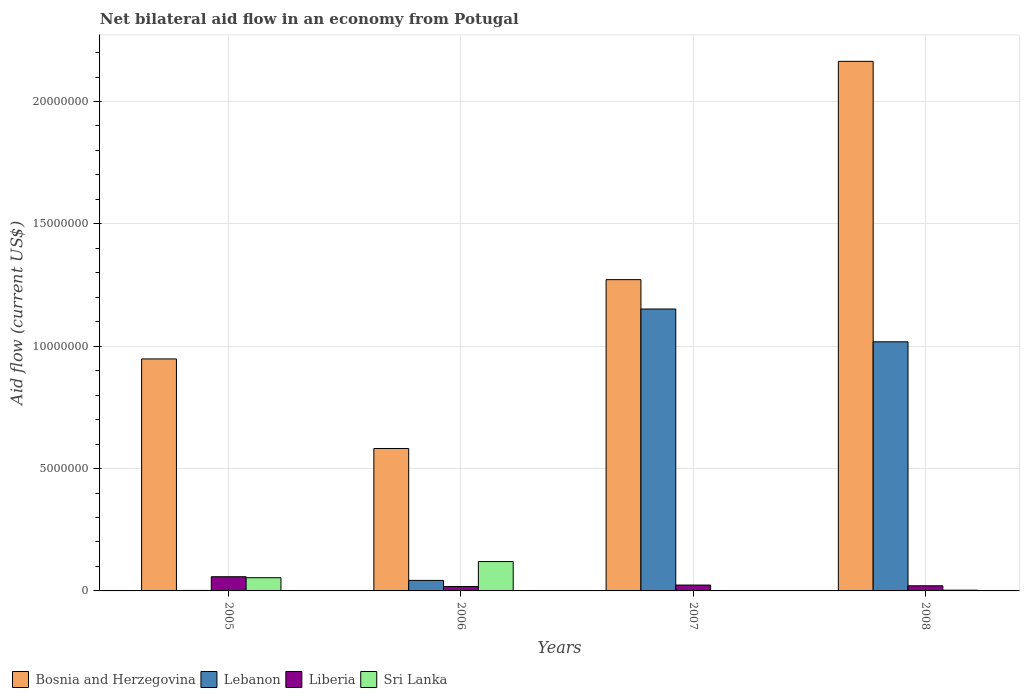How many groups of bars are there?
Offer a terse response. 4. Are the number of bars per tick equal to the number of legend labels?
Provide a short and direct response. Yes. How many bars are there on the 2nd tick from the left?
Your response must be concise. 4. How many bars are there on the 4th tick from the right?
Your response must be concise. 4. What is the label of the 2nd group of bars from the left?
Provide a succinct answer. 2006. In how many cases, is the number of bars for a given year not equal to the number of legend labels?
Your answer should be compact. 0. What is the net bilateral aid flow in Lebanon in 2005?
Provide a succinct answer. 2.00e+04. Across all years, what is the maximum net bilateral aid flow in Bosnia and Herzegovina?
Your answer should be compact. 2.16e+07. Across all years, what is the minimum net bilateral aid flow in Bosnia and Herzegovina?
Provide a succinct answer. 5.82e+06. In which year was the net bilateral aid flow in Liberia maximum?
Your answer should be compact. 2005. In which year was the net bilateral aid flow in Bosnia and Herzegovina minimum?
Your answer should be compact. 2006. What is the total net bilateral aid flow in Liberia in the graph?
Offer a very short reply. 1.21e+06. What is the difference between the net bilateral aid flow in Bosnia and Herzegovina in 2005 and that in 2006?
Your response must be concise. 3.66e+06. What is the difference between the net bilateral aid flow in Lebanon in 2005 and the net bilateral aid flow in Liberia in 2006?
Provide a succinct answer. -1.60e+05. What is the average net bilateral aid flow in Liberia per year?
Provide a short and direct response. 3.02e+05. In the year 2007, what is the difference between the net bilateral aid flow in Bosnia and Herzegovina and net bilateral aid flow in Sri Lanka?
Your answer should be compact. 1.27e+07. What is the ratio of the net bilateral aid flow in Sri Lanka in 2006 to that in 2007?
Offer a terse response. 120. Is the net bilateral aid flow in Lebanon in 2005 less than that in 2008?
Make the answer very short. Yes. What is the difference between the highest and the second highest net bilateral aid flow in Sri Lanka?
Offer a terse response. 6.60e+05. What is the difference between the highest and the lowest net bilateral aid flow in Liberia?
Your response must be concise. 4.00e+05. In how many years, is the net bilateral aid flow in Lebanon greater than the average net bilateral aid flow in Lebanon taken over all years?
Make the answer very short. 2. Is it the case that in every year, the sum of the net bilateral aid flow in Sri Lanka and net bilateral aid flow in Bosnia and Herzegovina is greater than the sum of net bilateral aid flow in Liberia and net bilateral aid flow in Lebanon?
Give a very brief answer. Yes. What does the 3rd bar from the left in 2008 represents?
Offer a very short reply. Liberia. What does the 2nd bar from the right in 2007 represents?
Your answer should be very brief. Liberia. Is it the case that in every year, the sum of the net bilateral aid flow in Bosnia and Herzegovina and net bilateral aid flow in Sri Lanka is greater than the net bilateral aid flow in Liberia?
Your response must be concise. Yes. How many years are there in the graph?
Provide a short and direct response. 4. Does the graph contain any zero values?
Make the answer very short. No. How many legend labels are there?
Offer a terse response. 4. How are the legend labels stacked?
Your response must be concise. Horizontal. What is the title of the graph?
Your response must be concise. Net bilateral aid flow in an economy from Potugal. Does "Lesotho" appear as one of the legend labels in the graph?
Ensure brevity in your answer.  No. What is the label or title of the Y-axis?
Your answer should be very brief. Aid flow (current US$). What is the Aid flow (current US$) in Bosnia and Herzegovina in 2005?
Your answer should be very brief. 9.48e+06. What is the Aid flow (current US$) in Lebanon in 2005?
Keep it short and to the point. 2.00e+04. What is the Aid flow (current US$) in Liberia in 2005?
Make the answer very short. 5.80e+05. What is the Aid flow (current US$) of Sri Lanka in 2005?
Keep it short and to the point. 5.40e+05. What is the Aid flow (current US$) of Bosnia and Herzegovina in 2006?
Make the answer very short. 5.82e+06. What is the Aid flow (current US$) of Lebanon in 2006?
Give a very brief answer. 4.30e+05. What is the Aid flow (current US$) of Sri Lanka in 2006?
Ensure brevity in your answer.  1.20e+06. What is the Aid flow (current US$) in Bosnia and Herzegovina in 2007?
Give a very brief answer. 1.27e+07. What is the Aid flow (current US$) of Lebanon in 2007?
Offer a very short reply. 1.15e+07. What is the Aid flow (current US$) of Bosnia and Herzegovina in 2008?
Make the answer very short. 2.16e+07. What is the Aid flow (current US$) in Lebanon in 2008?
Your response must be concise. 1.02e+07. What is the Aid flow (current US$) in Liberia in 2008?
Your answer should be compact. 2.10e+05. Across all years, what is the maximum Aid flow (current US$) in Bosnia and Herzegovina?
Keep it short and to the point. 2.16e+07. Across all years, what is the maximum Aid flow (current US$) in Lebanon?
Provide a succinct answer. 1.15e+07. Across all years, what is the maximum Aid flow (current US$) of Liberia?
Offer a terse response. 5.80e+05. Across all years, what is the maximum Aid flow (current US$) in Sri Lanka?
Provide a short and direct response. 1.20e+06. Across all years, what is the minimum Aid flow (current US$) of Bosnia and Herzegovina?
Keep it short and to the point. 5.82e+06. Across all years, what is the minimum Aid flow (current US$) in Lebanon?
Provide a succinct answer. 2.00e+04. Across all years, what is the minimum Aid flow (current US$) of Liberia?
Offer a terse response. 1.80e+05. Across all years, what is the minimum Aid flow (current US$) of Sri Lanka?
Offer a very short reply. 10000. What is the total Aid flow (current US$) of Bosnia and Herzegovina in the graph?
Give a very brief answer. 4.97e+07. What is the total Aid flow (current US$) in Lebanon in the graph?
Your answer should be compact. 2.22e+07. What is the total Aid flow (current US$) in Liberia in the graph?
Offer a very short reply. 1.21e+06. What is the total Aid flow (current US$) of Sri Lanka in the graph?
Your response must be concise. 1.78e+06. What is the difference between the Aid flow (current US$) of Bosnia and Herzegovina in 2005 and that in 2006?
Provide a short and direct response. 3.66e+06. What is the difference between the Aid flow (current US$) in Lebanon in 2005 and that in 2006?
Your response must be concise. -4.10e+05. What is the difference between the Aid flow (current US$) of Liberia in 2005 and that in 2006?
Make the answer very short. 4.00e+05. What is the difference between the Aid flow (current US$) of Sri Lanka in 2005 and that in 2006?
Ensure brevity in your answer.  -6.60e+05. What is the difference between the Aid flow (current US$) in Bosnia and Herzegovina in 2005 and that in 2007?
Your response must be concise. -3.24e+06. What is the difference between the Aid flow (current US$) in Lebanon in 2005 and that in 2007?
Your answer should be very brief. -1.15e+07. What is the difference between the Aid flow (current US$) in Sri Lanka in 2005 and that in 2007?
Your response must be concise. 5.30e+05. What is the difference between the Aid flow (current US$) of Bosnia and Herzegovina in 2005 and that in 2008?
Your answer should be compact. -1.22e+07. What is the difference between the Aid flow (current US$) of Lebanon in 2005 and that in 2008?
Ensure brevity in your answer.  -1.02e+07. What is the difference between the Aid flow (current US$) in Liberia in 2005 and that in 2008?
Your answer should be compact. 3.70e+05. What is the difference between the Aid flow (current US$) of Sri Lanka in 2005 and that in 2008?
Your answer should be very brief. 5.10e+05. What is the difference between the Aid flow (current US$) of Bosnia and Herzegovina in 2006 and that in 2007?
Offer a terse response. -6.90e+06. What is the difference between the Aid flow (current US$) of Lebanon in 2006 and that in 2007?
Ensure brevity in your answer.  -1.11e+07. What is the difference between the Aid flow (current US$) of Liberia in 2006 and that in 2007?
Keep it short and to the point. -6.00e+04. What is the difference between the Aid flow (current US$) of Sri Lanka in 2006 and that in 2007?
Your answer should be compact. 1.19e+06. What is the difference between the Aid flow (current US$) in Bosnia and Herzegovina in 2006 and that in 2008?
Keep it short and to the point. -1.58e+07. What is the difference between the Aid flow (current US$) of Lebanon in 2006 and that in 2008?
Make the answer very short. -9.75e+06. What is the difference between the Aid flow (current US$) in Liberia in 2006 and that in 2008?
Your response must be concise. -3.00e+04. What is the difference between the Aid flow (current US$) in Sri Lanka in 2006 and that in 2008?
Offer a very short reply. 1.17e+06. What is the difference between the Aid flow (current US$) in Bosnia and Herzegovina in 2007 and that in 2008?
Offer a terse response. -8.92e+06. What is the difference between the Aid flow (current US$) of Lebanon in 2007 and that in 2008?
Keep it short and to the point. 1.34e+06. What is the difference between the Aid flow (current US$) of Sri Lanka in 2007 and that in 2008?
Keep it short and to the point. -2.00e+04. What is the difference between the Aid flow (current US$) in Bosnia and Herzegovina in 2005 and the Aid flow (current US$) in Lebanon in 2006?
Offer a terse response. 9.05e+06. What is the difference between the Aid flow (current US$) of Bosnia and Herzegovina in 2005 and the Aid flow (current US$) of Liberia in 2006?
Provide a succinct answer. 9.30e+06. What is the difference between the Aid flow (current US$) in Bosnia and Herzegovina in 2005 and the Aid flow (current US$) in Sri Lanka in 2006?
Provide a short and direct response. 8.28e+06. What is the difference between the Aid flow (current US$) in Lebanon in 2005 and the Aid flow (current US$) in Liberia in 2006?
Keep it short and to the point. -1.60e+05. What is the difference between the Aid flow (current US$) of Lebanon in 2005 and the Aid flow (current US$) of Sri Lanka in 2006?
Provide a succinct answer. -1.18e+06. What is the difference between the Aid flow (current US$) of Liberia in 2005 and the Aid flow (current US$) of Sri Lanka in 2006?
Your answer should be compact. -6.20e+05. What is the difference between the Aid flow (current US$) in Bosnia and Herzegovina in 2005 and the Aid flow (current US$) in Lebanon in 2007?
Keep it short and to the point. -2.04e+06. What is the difference between the Aid flow (current US$) in Bosnia and Herzegovina in 2005 and the Aid flow (current US$) in Liberia in 2007?
Offer a terse response. 9.24e+06. What is the difference between the Aid flow (current US$) of Bosnia and Herzegovina in 2005 and the Aid flow (current US$) of Sri Lanka in 2007?
Your answer should be compact. 9.47e+06. What is the difference between the Aid flow (current US$) in Lebanon in 2005 and the Aid flow (current US$) in Sri Lanka in 2007?
Offer a very short reply. 10000. What is the difference between the Aid flow (current US$) in Liberia in 2005 and the Aid flow (current US$) in Sri Lanka in 2007?
Make the answer very short. 5.70e+05. What is the difference between the Aid flow (current US$) in Bosnia and Herzegovina in 2005 and the Aid flow (current US$) in Lebanon in 2008?
Provide a short and direct response. -7.00e+05. What is the difference between the Aid flow (current US$) in Bosnia and Herzegovina in 2005 and the Aid flow (current US$) in Liberia in 2008?
Your response must be concise. 9.27e+06. What is the difference between the Aid flow (current US$) in Bosnia and Herzegovina in 2005 and the Aid flow (current US$) in Sri Lanka in 2008?
Ensure brevity in your answer.  9.45e+06. What is the difference between the Aid flow (current US$) of Lebanon in 2005 and the Aid flow (current US$) of Liberia in 2008?
Provide a short and direct response. -1.90e+05. What is the difference between the Aid flow (current US$) of Lebanon in 2005 and the Aid flow (current US$) of Sri Lanka in 2008?
Provide a succinct answer. -10000. What is the difference between the Aid flow (current US$) in Bosnia and Herzegovina in 2006 and the Aid flow (current US$) in Lebanon in 2007?
Make the answer very short. -5.70e+06. What is the difference between the Aid flow (current US$) of Bosnia and Herzegovina in 2006 and the Aid flow (current US$) of Liberia in 2007?
Give a very brief answer. 5.58e+06. What is the difference between the Aid flow (current US$) in Bosnia and Herzegovina in 2006 and the Aid flow (current US$) in Sri Lanka in 2007?
Provide a short and direct response. 5.81e+06. What is the difference between the Aid flow (current US$) of Lebanon in 2006 and the Aid flow (current US$) of Sri Lanka in 2007?
Provide a succinct answer. 4.20e+05. What is the difference between the Aid flow (current US$) in Bosnia and Herzegovina in 2006 and the Aid flow (current US$) in Lebanon in 2008?
Provide a succinct answer. -4.36e+06. What is the difference between the Aid flow (current US$) in Bosnia and Herzegovina in 2006 and the Aid flow (current US$) in Liberia in 2008?
Make the answer very short. 5.61e+06. What is the difference between the Aid flow (current US$) in Bosnia and Herzegovina in 2006 and the Aid flow (current US$) in Sri Lanka in 2008?
Provide a succinct answer. 5.79e+06. What is the difference between the Aid flow (current US$) in Lebanon in 2006 and the Aid flow (current US$) in Liberia in 2008?
Offer a terse response. 2.20e+05. What is the difference between the Aid flow (current US$) in Liberia in 2006 and the Aid flow (current US$) in Sri Lanka in 2008?
Make the answer very short. 1.50e+05. What is the difference between the Aid flow (current US$) of Bosnia and Herzegovina in 2007 and the Aid flow (current US$) of Lebanon in 2008?
Your answer should be very brief. 2.54e+06. What is the difference between the Aid flow (current US$) of Bosnia and Herzegovina in 2007 and the Aid flow (current US$) of Liberia in 2008?
Your answer should be compact. 1.25e+07. What is the difference between the Aid flow (current US$) in Bosnia and Herzegovina in 2007 and the Aid flow (current US$) in Sri Lanka in 2008?
Give a very brief answer. 1.27e+07. What is the difference between the Aid flow (current US$) of Lebanon in 2007 and the Aid flow (current US$) of Liberia in 2008?
Your answer should be compact. 1.13e+07. What is the difference between the Aid flow (current US$) of Lebanon in 2007 and the Aid flow (current US$) of Sri Lanka in 2008?
Your answer should be compact. 1.15e+07. What is the average Aid flow (current US$) of Bosnia and Herzegovina per year?
Make the answer very short. 1.24e+07. What is the average Aid flow (current US$) of Lebanon per year?
Offer a very short reply. 5.54e+06. What is the average Aid flow (current US$) in Liberia per year?
Offer a very short reply. 3.02e+05. What is the average Aid flow (current US$) in Sri Lanka per year?
Your answer should be compact. 4.45e+05. In the year 2005, what is the difference between the Aid flow (current US$) in Bosnia and Herzegovina and Aid flow (current US$) in Lebanon?
Your answer should be compact. 9.46e+06. In the year 2005, what is the difference between the Aid flow (current US$) of Bosnia and Herzegovina and Aid flow (current US$) of Liberia?
Offer a terse response. 8.90e+06. In the year 2005, what is the difference between the Aid flow (current US$) in Bosnia and Herzegovina and Aid flow (current US$) in Sri Lanka?
Offer a very short reply. 8.94e+06. In the year 2005, what is the difference between the Aid flow (current US$) in Lebanon and Aid flow (current US$) in Liberia?
Offer a terse response. -5.60e+05. In the year 2005, what is the difference between the Aid flow (current US$) of Lebanon and Aid flow (current US$) of Sri Lanka?
Offer a terse response. -5.20e+05. In the year 2005, what is the difference between the Aid flow (current US$) in Liberia and Aid flow (current US$) in Sri Lanka?
Your answer should be compact. 4.00e+04. In the year 2006, what is the difference between the Aid flow (current US$) of Bosnia and Herzegovina and Aid flow (current US$) of Lebanon?
Offer a very short reply. 5.39e+06. In the year 2006, what is the difference between the Aid flow (current US$) of Bosnia and Herzegovina and Aid flow (current US$) of Liberia?
Ensure brevity in your answer.  5.64e+06. In the year 2006, what is the difference between the Aid flow (current US$) in Bosnia and Herzegovina and Aid flow (current US$) in Sri Lanka?
Your answer should be very brief. 4.62e+06. In the year 2006, what is the difference between the Aid flow (current US$) of Lebanon and Aid flow (current US$) of Liberia?
Your answer should be compact. 2.50e+05. In the year 2006, what is the difference between the Aid flow (current US$) in Lebanon and Aid flow (current US$) in Sri Lanka?
Make the answer very short. -7.70e+05. In the year 2006, what is the difference between the Aid flow (current US$) in Liberia and Aid flow (current US$) in Sri Lanka?
Your answer should be compact. -1.02e+06. In the year 2007, what is the difference between the Aid flow (current US$) of Bosnia and Herzegovina and Aid flow (current US$) of Lebanon?
Your answer should be compact. 1.20e+06. In the year 2007, what is the difference between the Aid flow (current US$) in Bosnia and Herzegovina and Aid flow (current US$) in Liberia?
Make the answer very short. 1.25e+07. In the year 2007, what is the difference between the Aid flow (current US$) of Bosnia and Herzegovina and Aid flow (current US$) of Sri Lanka?
Make the answer very short. 1.27e+07. In the year 2007, what is the difference between the Aid flow (current US$) in Lebanon and Aid flow (current US$) in Liberia?
Keep it short and to the point. 1.13e+07. In the year 2007, what is the difference between the Aid flow (current US$) in Lebanon and Aid flow (current US$) in Sri Lanka?
Your response must be concise. 1.15e+07. In the year 2007, what is the difference between the Aid flow (current US$) of Liberia and Aid flow (current US$) of Sri Lanka?
Keep it short and to the point. 2.30e+05. In the year 2008, what is the difference between the Aid flow (current US$) of Bosnia and Herzegovina and Aid flow (current US$) of Lebanon?
Your answer should be very brief. 1.15e+07. In the year 2008, what is the difference between the Aid flow (current US$) in Bosnia and Herzegovina and Aid flow (current US$) in Liberia?
Provide a short and direct response. 2.14e+07. In the year 2008, what is the difference between the Aid flow (current US$) of Bosnia and Herzegovina and Aid flow (current US$) of Sri Lanka?
Your response must be concise. 2.16e+07. In the year 2008, what is the difference between the Aid flow (current US$) of Lebanon and Aid flow (current US$) of Liberia?
Make the answer very short. 9.97e+06. In the year 2008, what is the difference between the Aid flow (current US$) of Lebanon and Aid flow (current US$) of Sri Lanka?
Give a very brief answer. 1.02e+07. In the year 2008, what is the difference between the Aid flow (current US$) in Liberia and Aid flow (current US$) in Sri Lanka?
Provide a succinct answer. 1.80e+05. What is the ratio of the Aid flow (current US$) in Bosnia and Herzegovina in 2005 to that in 2006?
Offer a very short reply. 1.63. What is the ratio of the Aid flow (current US$) in Lebanon in 2005 to that in 2006?
Give a very brief answer. 0.05. What is the ratio of the Aid flow (current US$) in Liberia in 2005 to that in 2006?
Keep it short and to the point. 3.22. What is the ratio of the Aid flow (current US$) of Sri Lanka in 2005 to that in 2006?
Ensure brevity in your answer.  0.45. What is the ratio of the Aid flow (current US$) in Bosnia and Herzegovina in 2005 to that in 2007?
Provide a succinct answer. 0.75. What is the ratio of the Aid flow (current US$) in Lebanon in 2005 to that in 2007?
Provide a succinct answer. 0. What is the ratio of the Aid flow (current US$) of Liberia in 2005 to that in 2007?
Your response must be concise. 2.42. What is the ratio of the Aid flow (current US$) of Bosnia and Herzegovina in 2005 to that in 2008?
Offer a very short reply. 0.44. What is the ratio of the Aid flow (current US$) of Lebanon in 2005 to that in 2008?
Offer a terse response. 0. What is the ratio of the Aid flow (current US$) of Liberia in 2005 to that in 2008?
Provide a short and direct response. 2.76. What is the ratio of the Aid flow (current US$) of Bosnia and Herzegovina in 2006 to that in 2007?
Give a very brief answer. 0.46. What is the ratio of the Aid flow (current US$) in Lebanon in 2006 to that in 2007?
Your answer should be very brief. 0.04. What is the ratio of the Aid flow (current US$) of Sri Lanka in 2006 to that in 2007?
Offer a terse response. 120. What is the ratio of the Aid flow (current US$) of Bosnia and Herzegovina in 2006 to that in 2008?
Make the answer very short. 0.27. What is the ratio of the Aid flow (current US$) of Lebanon in 2006 to that in 2008?
Ensure brevity in your answer.  0.04. What is the ratio of the Aid flow (current US$) in Liberia in 2006 to that in 2008?
Make the answer very short. 0.86. What is the ratio of the Aid flow (current US$) in Sri Lanka in 2006 to that in 2008?
Give a very brief answer. 40. What is the ratio of the Aid flow (current US$) in Bosnia and Herzegovina in 2007 to that in 2008?
Offer a very short reply. 0.59. What is the ratio of the Aid flow (current US$) in Lebanon in 2007 to that in 2008?
Keep it short and to the point. 1.13. What is the ratio of the Aid flow (current US$) of Liberia in 2007 to that in 2008?
Your response must be concise. 1.14. What is the ratio of the Aid flow (current US$) in Sri Lanka in 2007 to that in 2008?
Your response must be concise. 0.33. What is the difference between the highest and the second highest Aid flow (current US$) in Bosnia and Herzegovina?
Provide a short and direct response. 8.92e+06. What is the difference between the highest and the second highest Aid flow (current US$) in Lebanon?
Keep it short and to the point. 1.34e+06. What is the difference between the highest and the second highest Aid flow (current US$) of Sri Lanka?
Make the answer very short. 6.60e+05. What is the difference between the highest and the lowest Aid flow (current US$) in Bosnia and Herzegovina?
Your response must be concise. 1.58e+07. What is the difference between the highest and the lowest Aid flow (current US$) in Lebanon?
Your answer should be compact. 1.15e+07. What is the difference between the highest and the lowest Aid flow (current US$) in Liberia?
Offer a terse response. 4.00e+05. What is the difference between the highest and the lowest Aid flow (current US$) of Sri Lanka?
Give a very brief answer. 1.19e+06. 